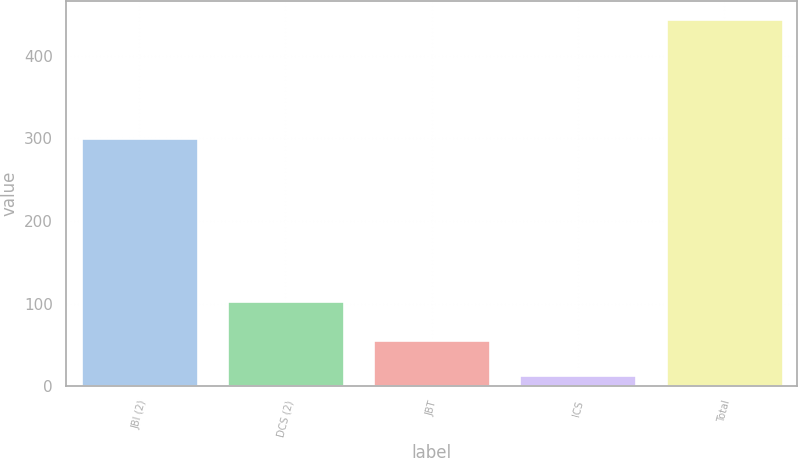Convert chart. <chart><loc_0><loc_0><loc_500><loc_500><bar_chart><fcel>JBI (2)<fcel>DCS (2)<fcel>JBT<fcel>ICS<fcel>Total<nl><fcel>301<fcel>103<fcel>56.1<fcel>13<fcel>444<nl></chart> 